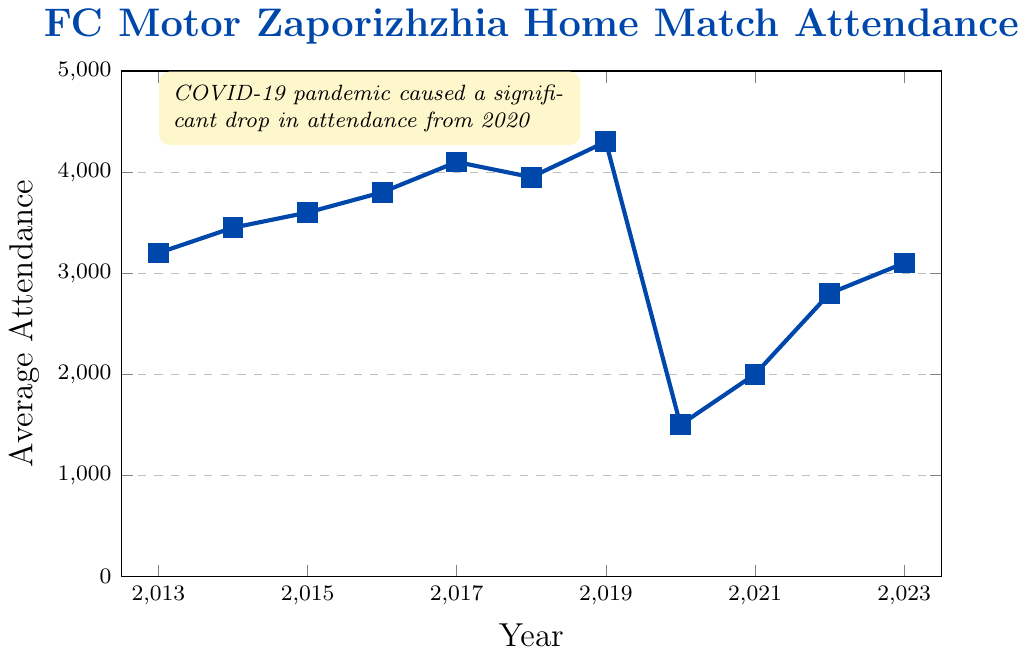What's the trend of average attendance at FC Motor Zaporizhzhia home matches from 2013 to 2019? Here, we observe the average attendance values year by year from 2013 to 2019. In 2013, attendance starts at 3200 and gradually increases every year, reaching 4300 in 2019. This indicates a general upward trend.
Answer: Upward trend What was the impact of the COVID-19 pandemic on the average attendance? The average attendance significantly dropped from 4300 in 2019 to 1500 in 2020, which is more than a 65% decrease.
Answer: Significant drop How does the average attendance in 2023 compare to the average attendance in 2020? In 2020, the average attendance was 1500, whereas in 2023, it increased to 3100, representing a significant increase over three years.
Answer: Increased What is the difference between the highest and lowest average attendance in the data? The highest average attendance is 4300 in 2019, and the lowest is 1500 in 2020. The difference between these values is 4300 - 1500, which equals 2800.
Answer: 2800 How did the average attendance change between 2018 and 2019? The average attendance increased from 3950 in 2018 to 4300 in 2019. This change can be calculated as 4300 - 3950, which is an increase of 350.
Answer: Increased by 350 In which year did the average attendance experience the highest increase compared to the previous year? By examining year-over-year changes, the highest increase can be observed from 2016 to 2017. The attendance increased from 3800 to 4100, giving us a change of 300 compared to other year-to-year changes which are smaller.
Answer: 2017 What is the average attendance for the years 2020 to 2023? To get the average attendance for these years, sum the values from 2020 (1500), 2021 (2000), 2022 (2800), and 2023 (3100) then divide by 4. Calculated: (1500 + 2000 + 2800 + 3100) / 4 = 2350.
Answer: 2350 What years experienced a decline in average attendance from the previous year? The years with a decline can be identified by comparing each year with the previous year. There are three such instances: from 2017 to 2018 (4100 to 3950), 2019 to 2020 (4300 to 1500), and 2021 to 2022 (2000 to 2800).
Answer: 2018, 2020, 2021 Which year had the highest average attendance, and what was the value? The highest average attendance was observed in 2019 with a value of 4300.
Answer: 2019, 4300 From which year to which year did the average attendance rise from the lowest to a value close to the initial (2013)? Starting from the lowest point in 2020 (1500), the average attendance increased and reached 3100 in 2023, close to the initial value of 3200 in 2013.
Answer: 2020 to 2023 